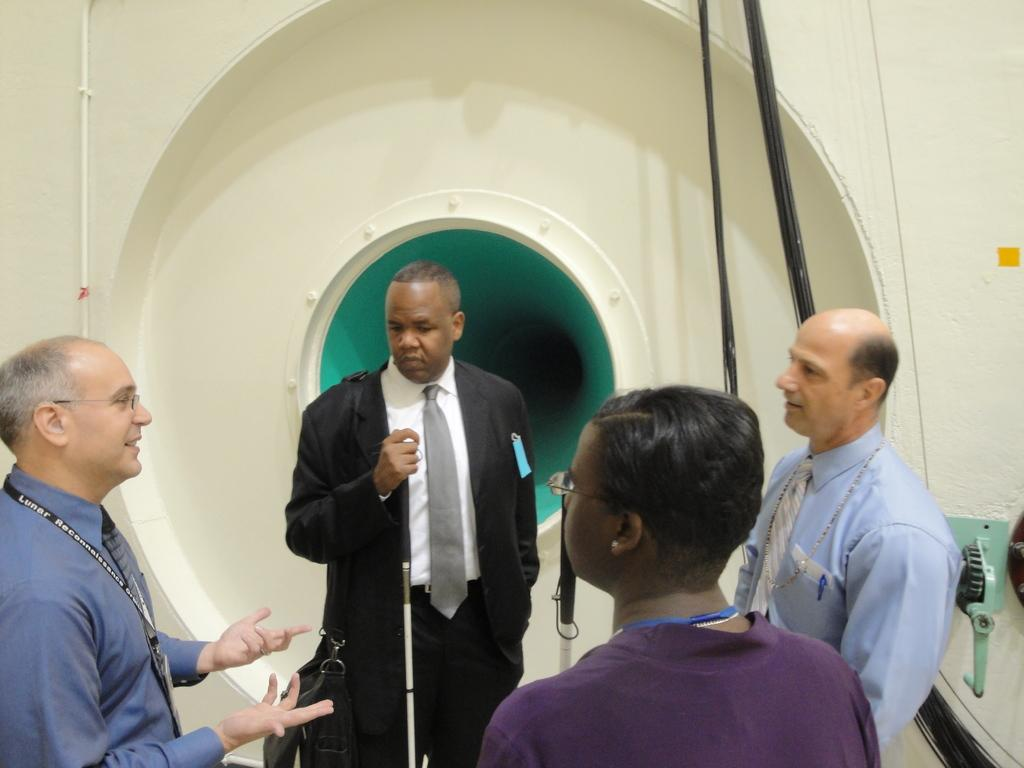How many people are in the image? There are people standing in the image, but the exact number is not specified. What is one person holding in the image? One person is holding a stick. What can be seen in the background of the image? There is a window, wires, and a wall visible in the background. What language is being spoken by the people in the image? The facts provided do not give any information about the language being spoken by the people in the image. 